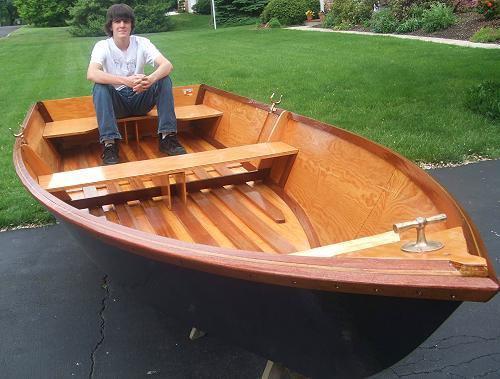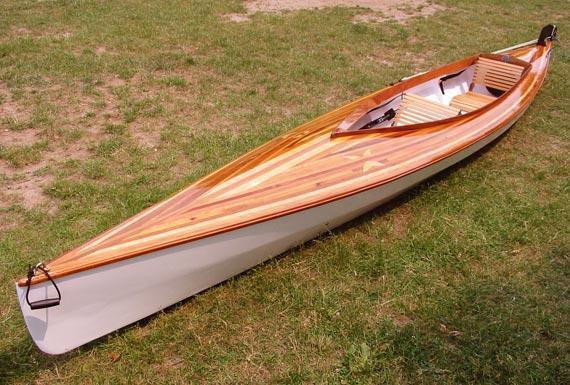The first image is the image on the left, the second image is the image on the right. For the images shown, is this caption "There are more than two boats visible." true? Answer yes or no. No. The first image is the image on the left, the second image is the image on the right. Assess this claim about the two images: "Each image shows a single prominent wooden boat, and the boats in the left and right images face the same general direction.". Correct or not? Answer yes or no. No. 